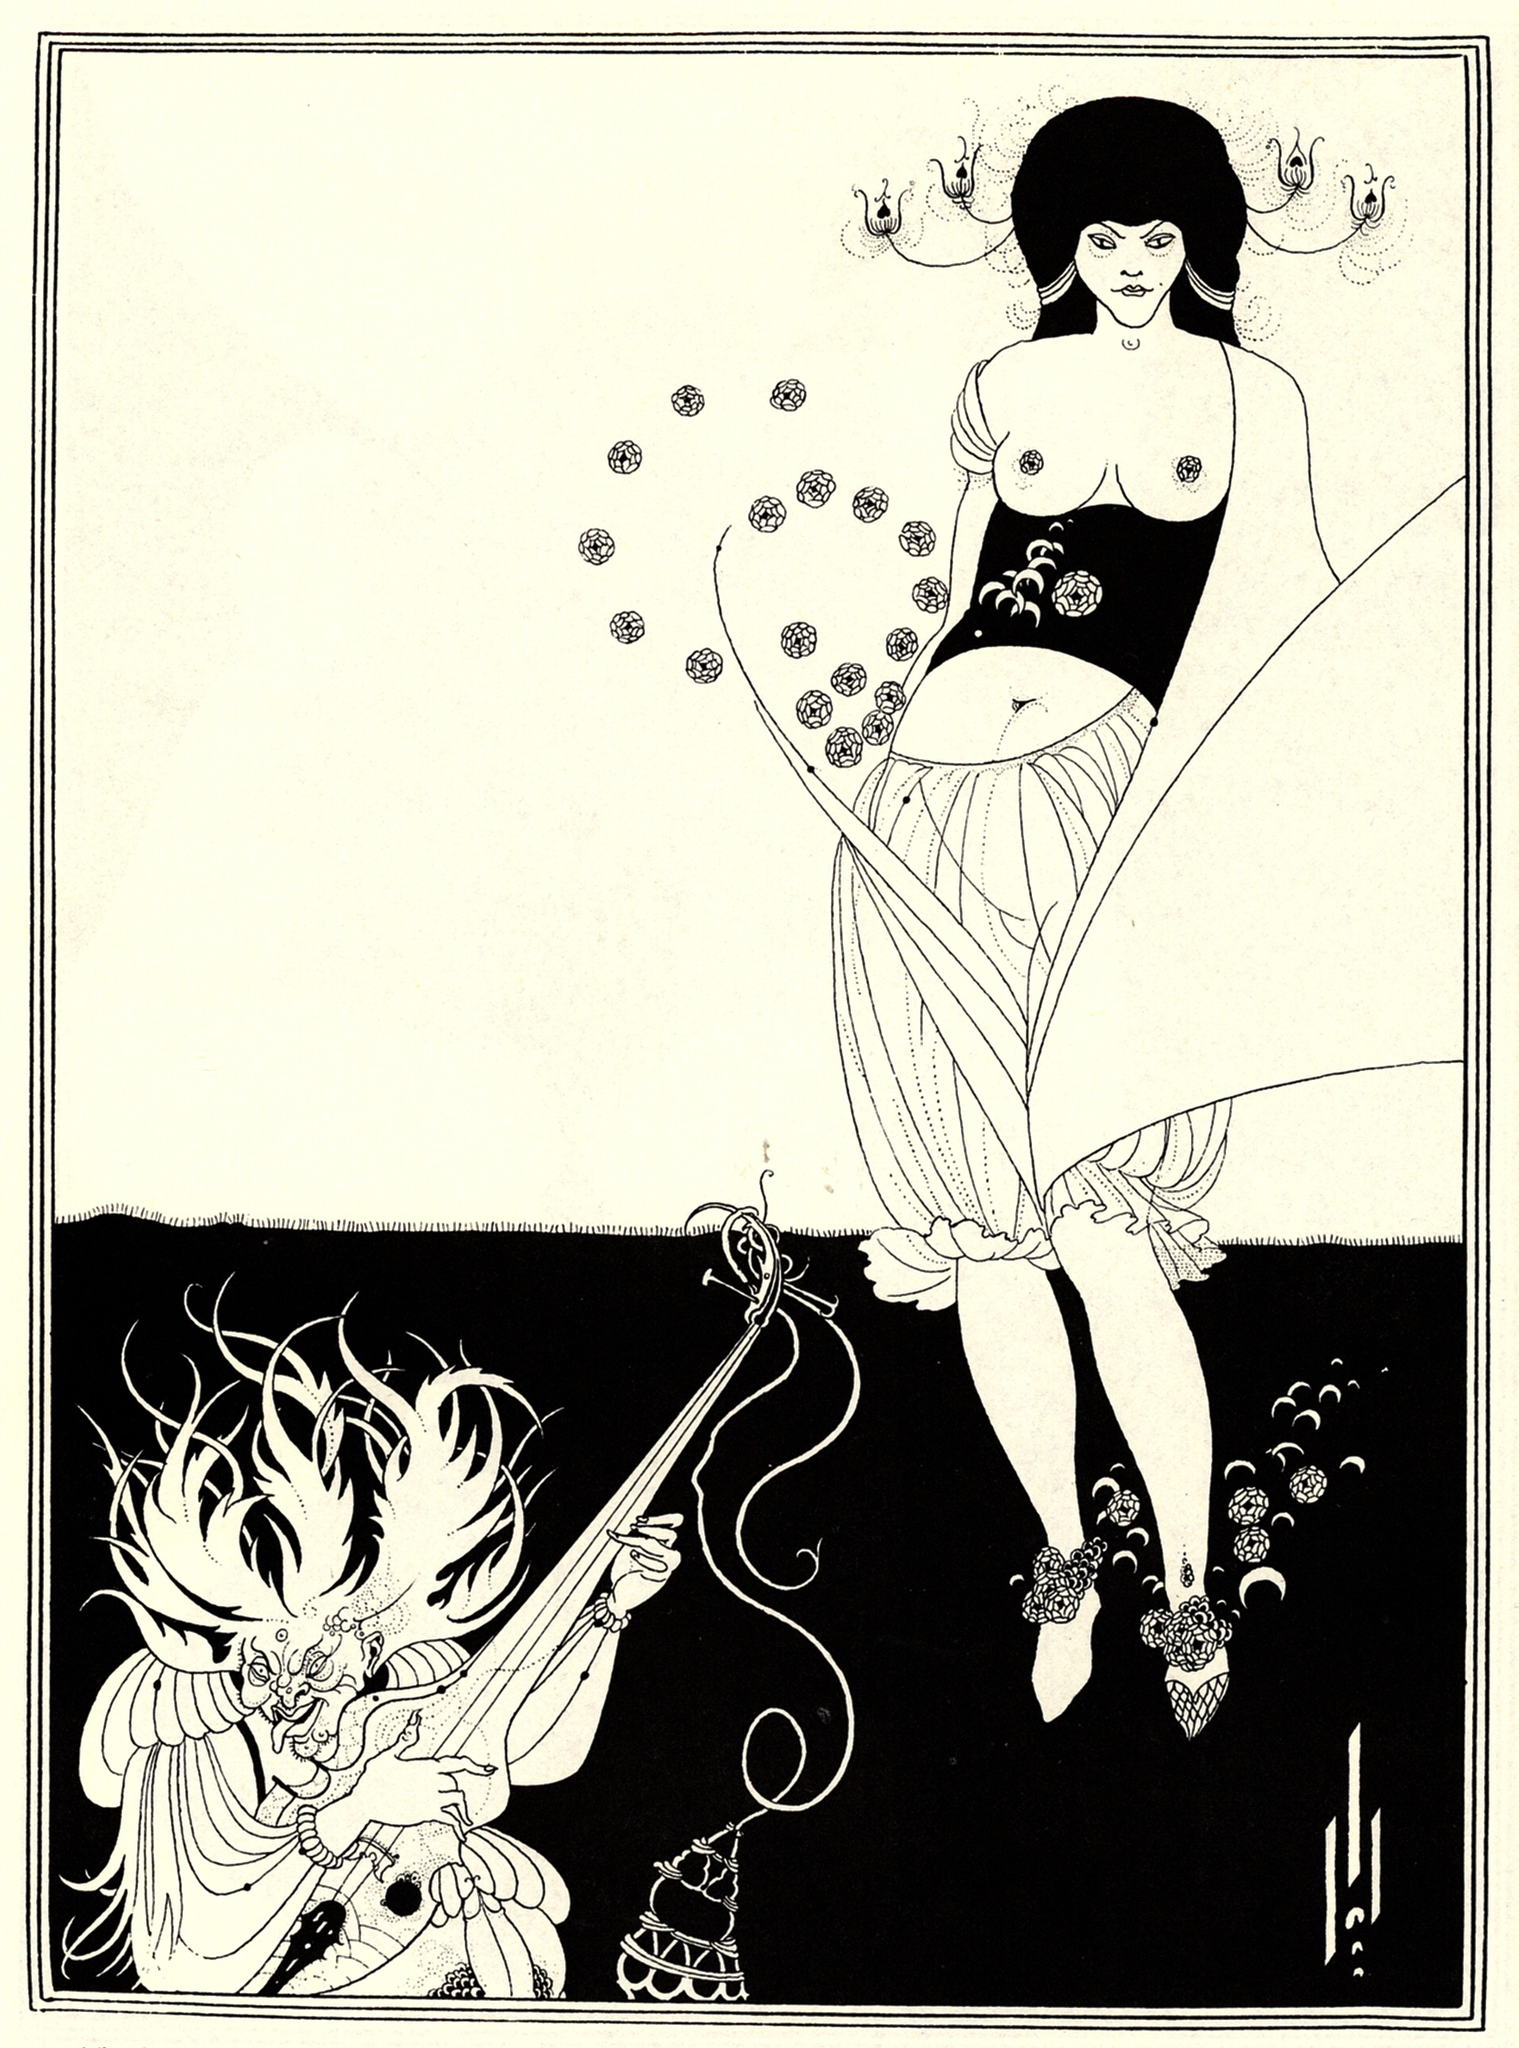How does the artist use body language in this scene? The artist uses body language to convey various emotions and dynamics between the characters. The woman’s posture, with her body facing forward and head turned to the side, suggests a mix of confidence and intrigue. Her extended arm and the object in her hand imply she is engaging with the dragon. The dragon's posture, holding a sword and censer, portrays a sense of readiness and mysticism. The overall body language creates an interaction that is both tense and mesmerizing. Can you elaborate on the historical context of the Art Nouveau style? Art Nouveau emerged in the late 19th and early 20th centuries as a response to the industrial revolution. It sought to break away from the rigid structures of traditional art and architecture by embracing organic, flowing forms inspired by nature. Artists in this movement often used floral and plant motifs, and their works were characterized by intricate designs and an emphasis on craftsmanship. The goal was to create a sense of harmony between human-made environments and the natural world, which is beautifully reflected in this artwork. 